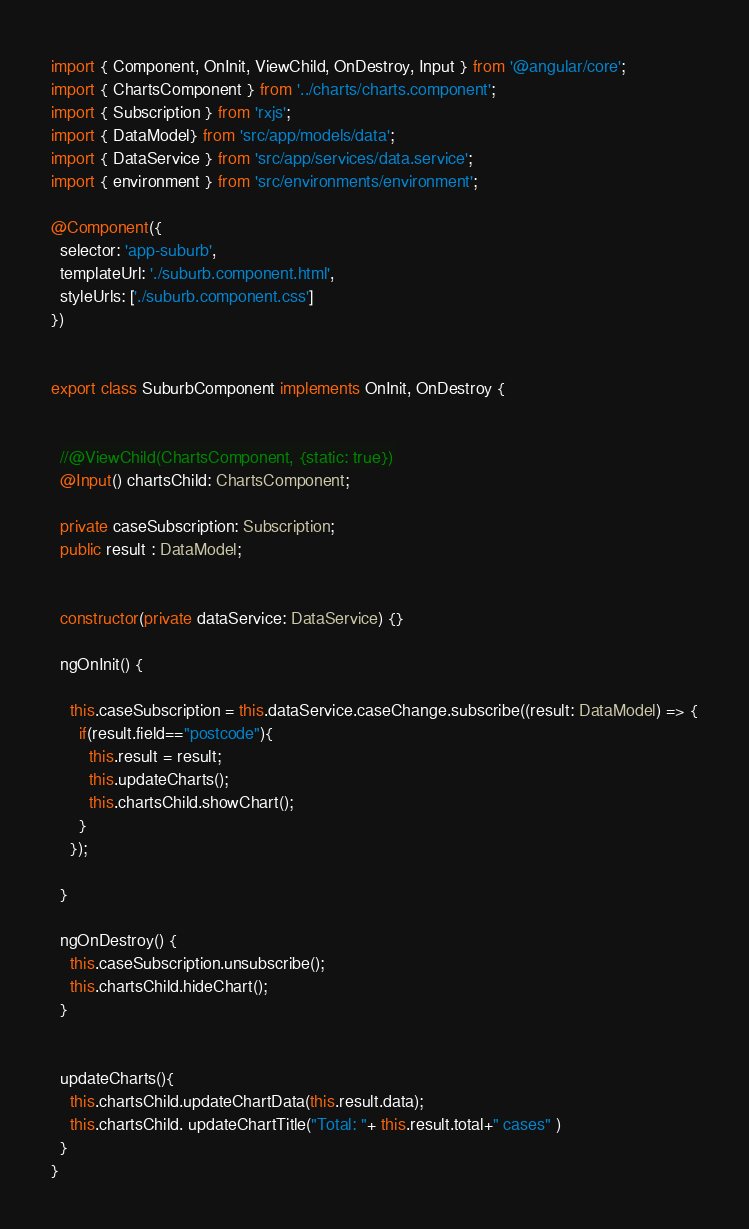<code> <loc_0><loc_0><loc_500><loc_500><_TypeScript_>import { Component, OnInit, ViewChild, OnDestroy, Input } from '@angular/core';
import { ChartsComponent } from '../charts/charts.component';
import { Subscription } from 'rxjs';
import { DataModel} from 'src/app/models/data';
import { DataService } from 'src/app/services/data.service';
import { environment } from 'src/environments/environment';

@Component({
  selector: 'app-suburb',
  templateUrl: './suburb.component.html',
  styleUrls: ['./suburb.component.css']
})


export class SuburbComponent implements OnInit, OnDestroy {


  //@ViewChild(ChartsComponent, {static: true})
  @Input() chartsChild: ChartsComponent;

  private caseSubscription: Subscription;
  public result : DataModel;


  constructor(private dataService: DataService) {}

  ngOnInit() {
   
    this.caseSubscription = this.dataService.caseChange.subscribe((result: DataModel) => {
      if(result.field=="postcode"){
        this.result = result;
        this.updateCharts();
        this.chartsChild.showChart();
      }
    });

  }

  ngOnDestroy() {
    this.caseSubscription.unsubscribe();
    this.chartsChild.hideChart();
  }


  updateCharts(){
    this.chartsChild.updateChartData(this.result.data);
    this.chartsChild. updateChartTitle("Total: "+ this.result.total+" cases" )
  }
}
</code> 